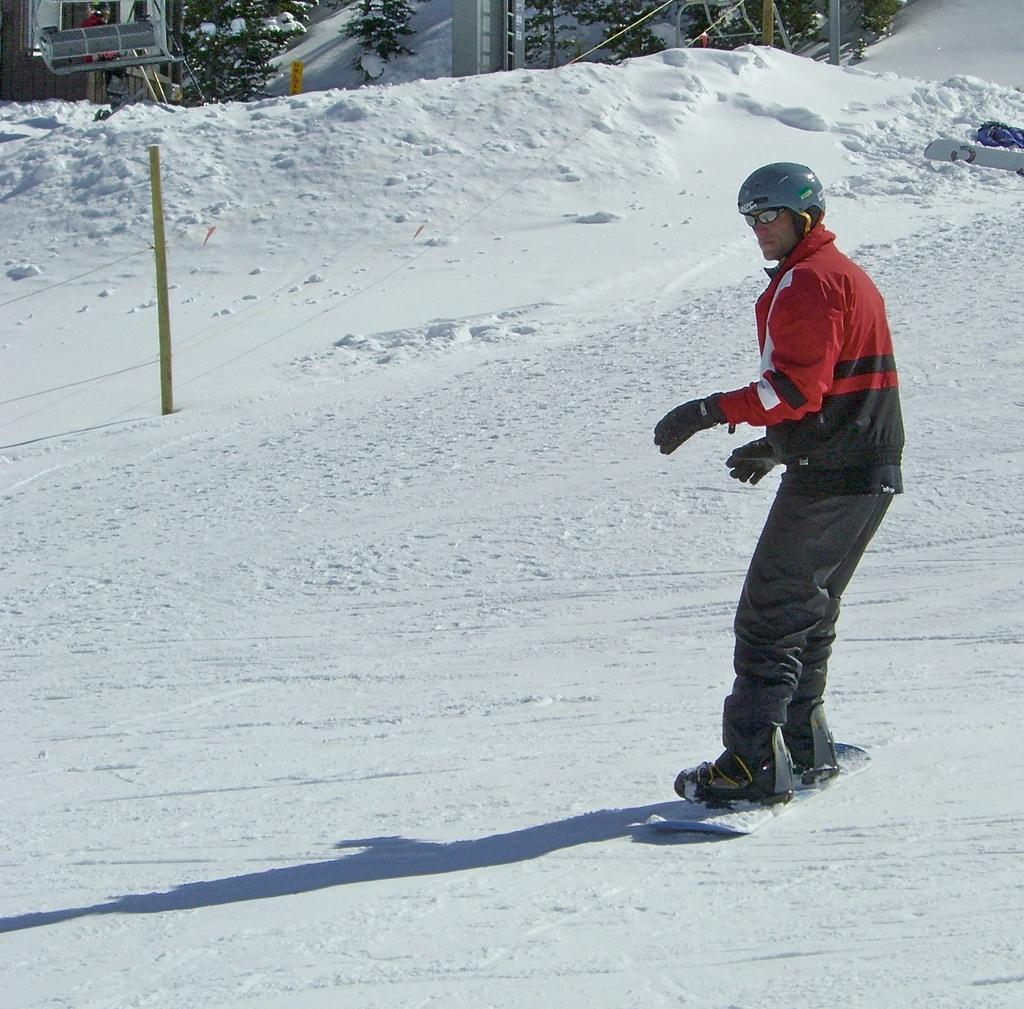Can you describe this image briefly? In this image, we can see a person is skating with a snowboard on the snow. He is wearing a helmet, goggles and gloves. Top of the image, we can see poles, trees, few objects and person. 